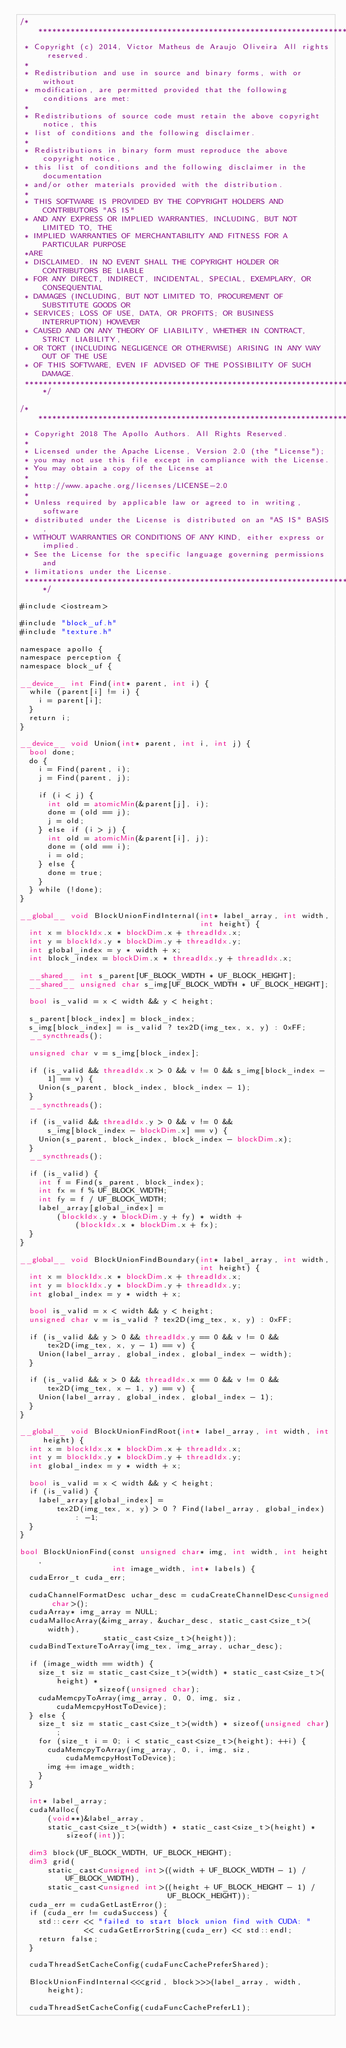<code> <loc_0><loc_0><loc_500><loc_500><_Cuda_>/******************************************************************************
 * Copyright (c) 2014, Victor Matheus de Araujo Oliveira All rights reserved.
 *
 * Redistribution and use in source and binary forms, with or without
 * modification, are permitted provided that the following conditions are met:
 *
 * Redistributions of source code must retain the above copyright notice, this
 * list of conditions and the following disclaimer.
 *
 * Redistributions in binary form must reproduce the above copyright notice,
 * this list of conditions and the following disclaimer in the documentation
 * and/or other materials provided with the distribution.
 *
 * THIS SOFTWARE IS PROVIDED BY THE COPYRIGHT HOLDERS AND CONTRIBUTORS "AS IS"
 * AND ANY EXPRESS OR IMPLIED WARRANTIES, INCLUDING, BUT NOT LIMITED TO, THE
 * IMPLIED WARRANTIES OF MERCHANTABILITY AND FITNESS FOR A PARTICULAR PURPOSE
 *ARE
 * DISCLAIMED. IN NO EVENT SHALL THE COPYRIGHT HOLDER OR CONTRIBUTORS BE LIABLE
 * FOR ANY DIRECT, INDIRECT, INCIDENTAL, SPECIAL, EXEMPLARY, OR CONSEQUENTIAL
 * DAMAGES (INCLUDING, BUT NOT LIMITED TO, PROCUREMENT OF SUBSTITUTE GOODS OR
 * SERVICES; LOSS OF USE, DATA, OR PROFITS; OR BUSINESS INTERRUPTION) HOWEVER
 * CAUSED AND ON ANY THEORY OF LIABILITY, WHETHER IN CONTRACT, STRICT LIABILITY,
 * OR TORT (INCLUDING NEGLIGENCE OR OTHERWISE) ARISING IN ANY WAY OUT OF THE USE
 * OF THIS SOFTWARE, EVEN IF ADVISED OF THE POSSIBILITY OF SUCH DAMAGE.
 *****************************************************************************/

/******************************************************************************
 * Copyright 2018 The Apollo Authors. All Rights Reserved.
 *
 * Licensed under the Apache License, Version 2.0 (the "License");
 * you may not use this file except in compliance with the License.
 * You may obtain a copy of the License at
 *
 * http://www.apache.org/licenses/LICENSE-2.0
 *
 * Unless required by applicable law or agreed to in writing, software
 * distributed under the License is distributed on an "AS IS" BASIS,
 * WITHOUT WARRANTIES OR CONDITIONS OF ANY KIND, either express or implied.
 * See the License for the specific language governing permissions and
 * limitations under the License.
 *****************************************************************************/

#include <iostream>

#include "block_uf.h"
#include "texture.h"

namespace apollo {
namespace perception {
namespace block_uf {

__device__ int Find(int* parent, int i) {
  while (parent[i] != i) {
    i = parent[i];
  }
  return i;
}

__device__ void Union(int* parent, int i, int j) {
  bool done;
  do {
    i = Find(parent, i);
    j = Find(parent, j);

    if (i < j) {
      int old = atomicMin(&parent[j], i);
      done = (old == j);
      j = old;
    } else if (i > j) {
      int old = atomicMin(&parent[i], j);
      done = (old == i);
      i = old;
    } else {
      done = true;
    }
  } while (!done);
}

__global__ void BlockUnionFindInternal(int* label_array, int width,
                                       int height) {
  int x = blockIdx.x * blockDim.x + threadIdx.x;
  int y = blockIdx.y * blockDim.y + threadIdx.y;
  int global_index = y * width + x;
  int block_index = blockDim.x * threadIdx.y + threadIdx.x;

  __shared__ int s_parent[UF_BLOCK_WIDTH * UF_BLOCK_HEIGHT];
  __shared__ unsigned char s_img[UF_BLOCK_WIDTH * UF_BLOCK_HEIGHT];

  bool is_valid = x < width && y < height;

  s_parent[block_index] = block_index;
  s_img[block_index] = is_valid ? tex2D(img_tex, x, y) : 0xFF;
  __syncthreads();

  unsigned char v = s_img[block_index];

  if (is_valid && threadIdx.x > 0 && v != 0 && s_img[block_index - 1] == v) {
    Union(s_parent, block_index, block_index - 1);
  }
  __syncthreads();

  if (is_valid && threadIdx.y > 0 && v != 0 &&
      s_img[block_index - blockDim.x] == v) {
    Union(s_parent, block_index, block_index - blockDim.x);
  }
  __syncthreads();

  if (is_valid) {
    int f = Find(s_parent, block_index);
    int fx = f % UF_BLOCK_WIDTH;
    int fy = f / UF_BLOCK_WIDTH;
    label_array[global_index] =
        (blockIdx.y * blockDim.y + fy) * width +
            (blockIdx.x * blockDim.x + fx);
  }
}

__global__ void BlockUnionFindBoundary(int* label_array, int width,
                                       int height) {
  int x = blockIdx.x * blockDim.x + threadIdx.x;
  int y = blockIdx.y * blockDim.y + threadIdx.y;
  int global_index = y * width + x;

  bool is_valid = x < width && y < height;
  unsigned char v = is_valid ? tex2D(img_tex, x, y) : 0xFF;

  if (is_valid && y > 0 && threadIdx.y == 0 && v != 0 &&
      tex2D(img_tex, x, y - 1) == v) {
    Union(label_array, global_index, global_index - width);
  }

  if (is_valid && x > 0 && threadIdx.x == 0 && v != 0 &&
      tex2D(img_tex, x - 1, y) == v) {
    Union(label_array, global_index, global_index - 1);
  }
}

__global__ void BlockUnionFindRoot(int* label_array, int width, int height) {
  int x = blockIdx.x * blockDim.x + threadIdx.x;
  int y = blockIdx.y * blockDim.y + threadIdx.y;
  int global_index = y * width + x;

  bool is_valid = x < width && y < height;
  if (is_valid) {
    label_array[global_index] =
        tex2D(img_tex, x, y) > 0 ? Find(label_array, global_index) : -1;
  }
}

bool BlockUnionFind(const unsigned char* img, int width, int height,
                    int image_width, int* labels) {
  cudaError_t cuda_err;

  cudaChannelFormatDesc uchar_desc = cudaCreateChannelDesc<unsigned char>();
  cudaArray* img_array = NULL;
  cudaMallocArray(&img_array, &uchar_desc, static_cast<size_t>(width),
                  static_cast<size_t>(height));
  cudaBindTextureToArray(img_tex, img_array, uchar_desc);

  if (image_width == width) {
    size_t siz = static_cast<size_t>(width) * static_cast<size_t>(height) *
                 sizeof(unsigned char);
    cudaMemcpyToArray(img_array, 0, 0, img, siz, cudaMemcpyHostToDevice);
  } else {
    size_t siz = static_cast<size_t>(width) * sizeof(unsigned char);
    for (size_t i = 0; i < static_cast<size_t>(height); ++i) {
      cudaMemcpyToArray(img_array, 0, i, img, siz, cudaMemcpyHostToDevice);
      img += image_width;
    }
  }

  int* label_array;
  cudaMalloc(
      (void**)&label_array,
      static_cast<size_t>(width) * static_cast<size_t>(height) * sizeof(int));

  dim3 block(UF_BLOCK_WIDTH, UF_BLOCK_HEIGHT);
  dim3 grid(
      static_cast<unsigned int>((width + UF_BLOCK_WIDTH - 1) / UF_BLOCK_WIDTH),
      static_cast<unsigned int>((height + UF_BLOCK_HEIGHT - 1) /
                                UF_BLOCK_HEIGHT));
  cuda_err = cudaGetLastError();
  if (cuda_err != cudaSuccess) {
    std::cerr << "failed to start block union find with CUDA: "
              << cudaGetErrorString(cuda_err) << std::endl;
    return false;
  }

  cudaThreadSetCacheConfig(cudaFuncCachePreferShared);

  BlockUnionFindInternal<<<grid, block>>>(label_array, width, height);

  cudaThreadSetCacheConfig(cudaFuncCachePreferL1);
</code> 